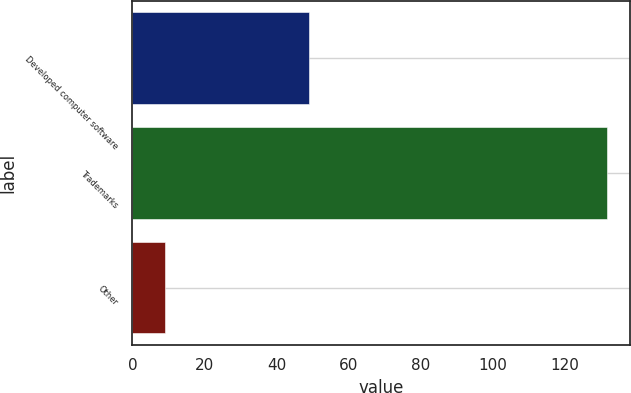Convert chart. <chart><loc_0><loc_0><loc_500><loc_500><bar_chart><fcel>Developed computer software<fcel>Trademarks<fcel>Other<nl><fcel>48.9<fcel>131.5<fcel>9.1<nl></chart> 